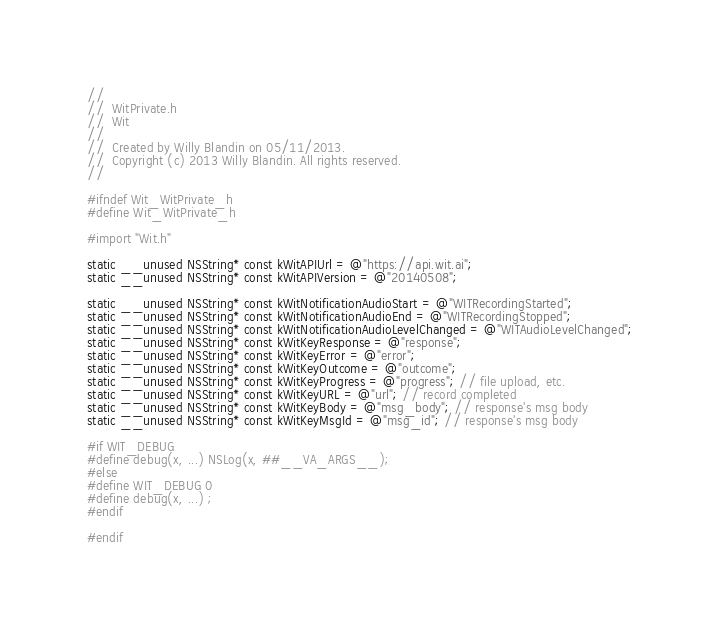<code> <loc_0><loc_0><loc_500><loc_500><_C_>//
//  WitPrivate.h
//  Wit
//
//  Created by Willy Blandin on 05/11/2013.
//  Copyright (c) 2013 Willy Blandin. All rights reserved.
//

#ifndef Wit_WitPrivate_h
#define Wit_WitPrivate_h

#import "Wit.h"

static __unused NSString* const kWitAPIUrl = @"https://api.wit.ai";
static __unused NSString* const kWitAPIVersion = @"20140508";

static __unused NSString* const kWitNotificationAudioStart = @"WITRecordingStarted";
static __unused NSString* const kWitNotificationAudioEnd = @"WITRecordingStopped";
static __unused NSString* const kWitNotificationAudioLevelChanged = @"WITAudioLevelChanged";
static __unused NSString* const kWitKeyResponse = @"response";
static __unused NSString* const kWitKeyError = @"error";
static __unused NSString* const kWitKeyOutcome = @"outcome";
static __unused NSString* const kWitKeyProgress = @"progress"; // file upload, etc.
static __unused NSString* const kWitKeyURL = @"url"; // record completed
static __unused NSString* const kWitKeyBody = @"msg_body"; // response's msg body
static __unused NSString* const kWitKeyMsgId = @"msg_id"; // response's msg body

#if WIT_DEBUG
#define debug(x, ...) NSLog(x, ##__VA_ARGS__);
#else
#define WIT_DEBUG 0
#define debug(x, ...) ;
#endif

#endif
</code> 